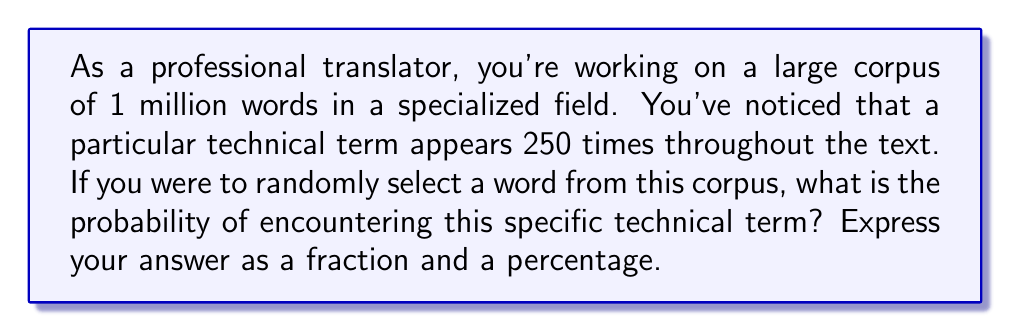What is the answer to this math problem? Let's approach this step-by-step:

1) First, we need to identify the key information:
   - Total number of words in the corpus: 1,000,000
   - Number of occurrences of the specific technical term: 250

2) The probability of an event is calculated by dividing the number of favorable outcomes by the total number of possible outcomes:

   $$P(\text{event}) = \frac{\text{number of favorable outcomes}}{\text{total number of possible outcomes}}$$

3) In this case:
   - Favorable outcomes: 250 (occurrences of the term)
   - Total possible outcomes: 1,000,000 (total words in the corpus)

4) Let's calculate the probability:

   $$P(\text{selecting the technical term}) = \frac{250}{1,000,000} = \frac{1}{4,000}$$

5) To express this as a percentage, we multiply by 100:

   $$\frac{1}{4,000} \times 100 = 0.025\%$$

Therefore, the probability of randomly selecting this specific technical term is $\frac{1}{4,000}$ or $0.025\%$.
Answer: $\frac{1}{4,000}$ or $0.025\%$ 